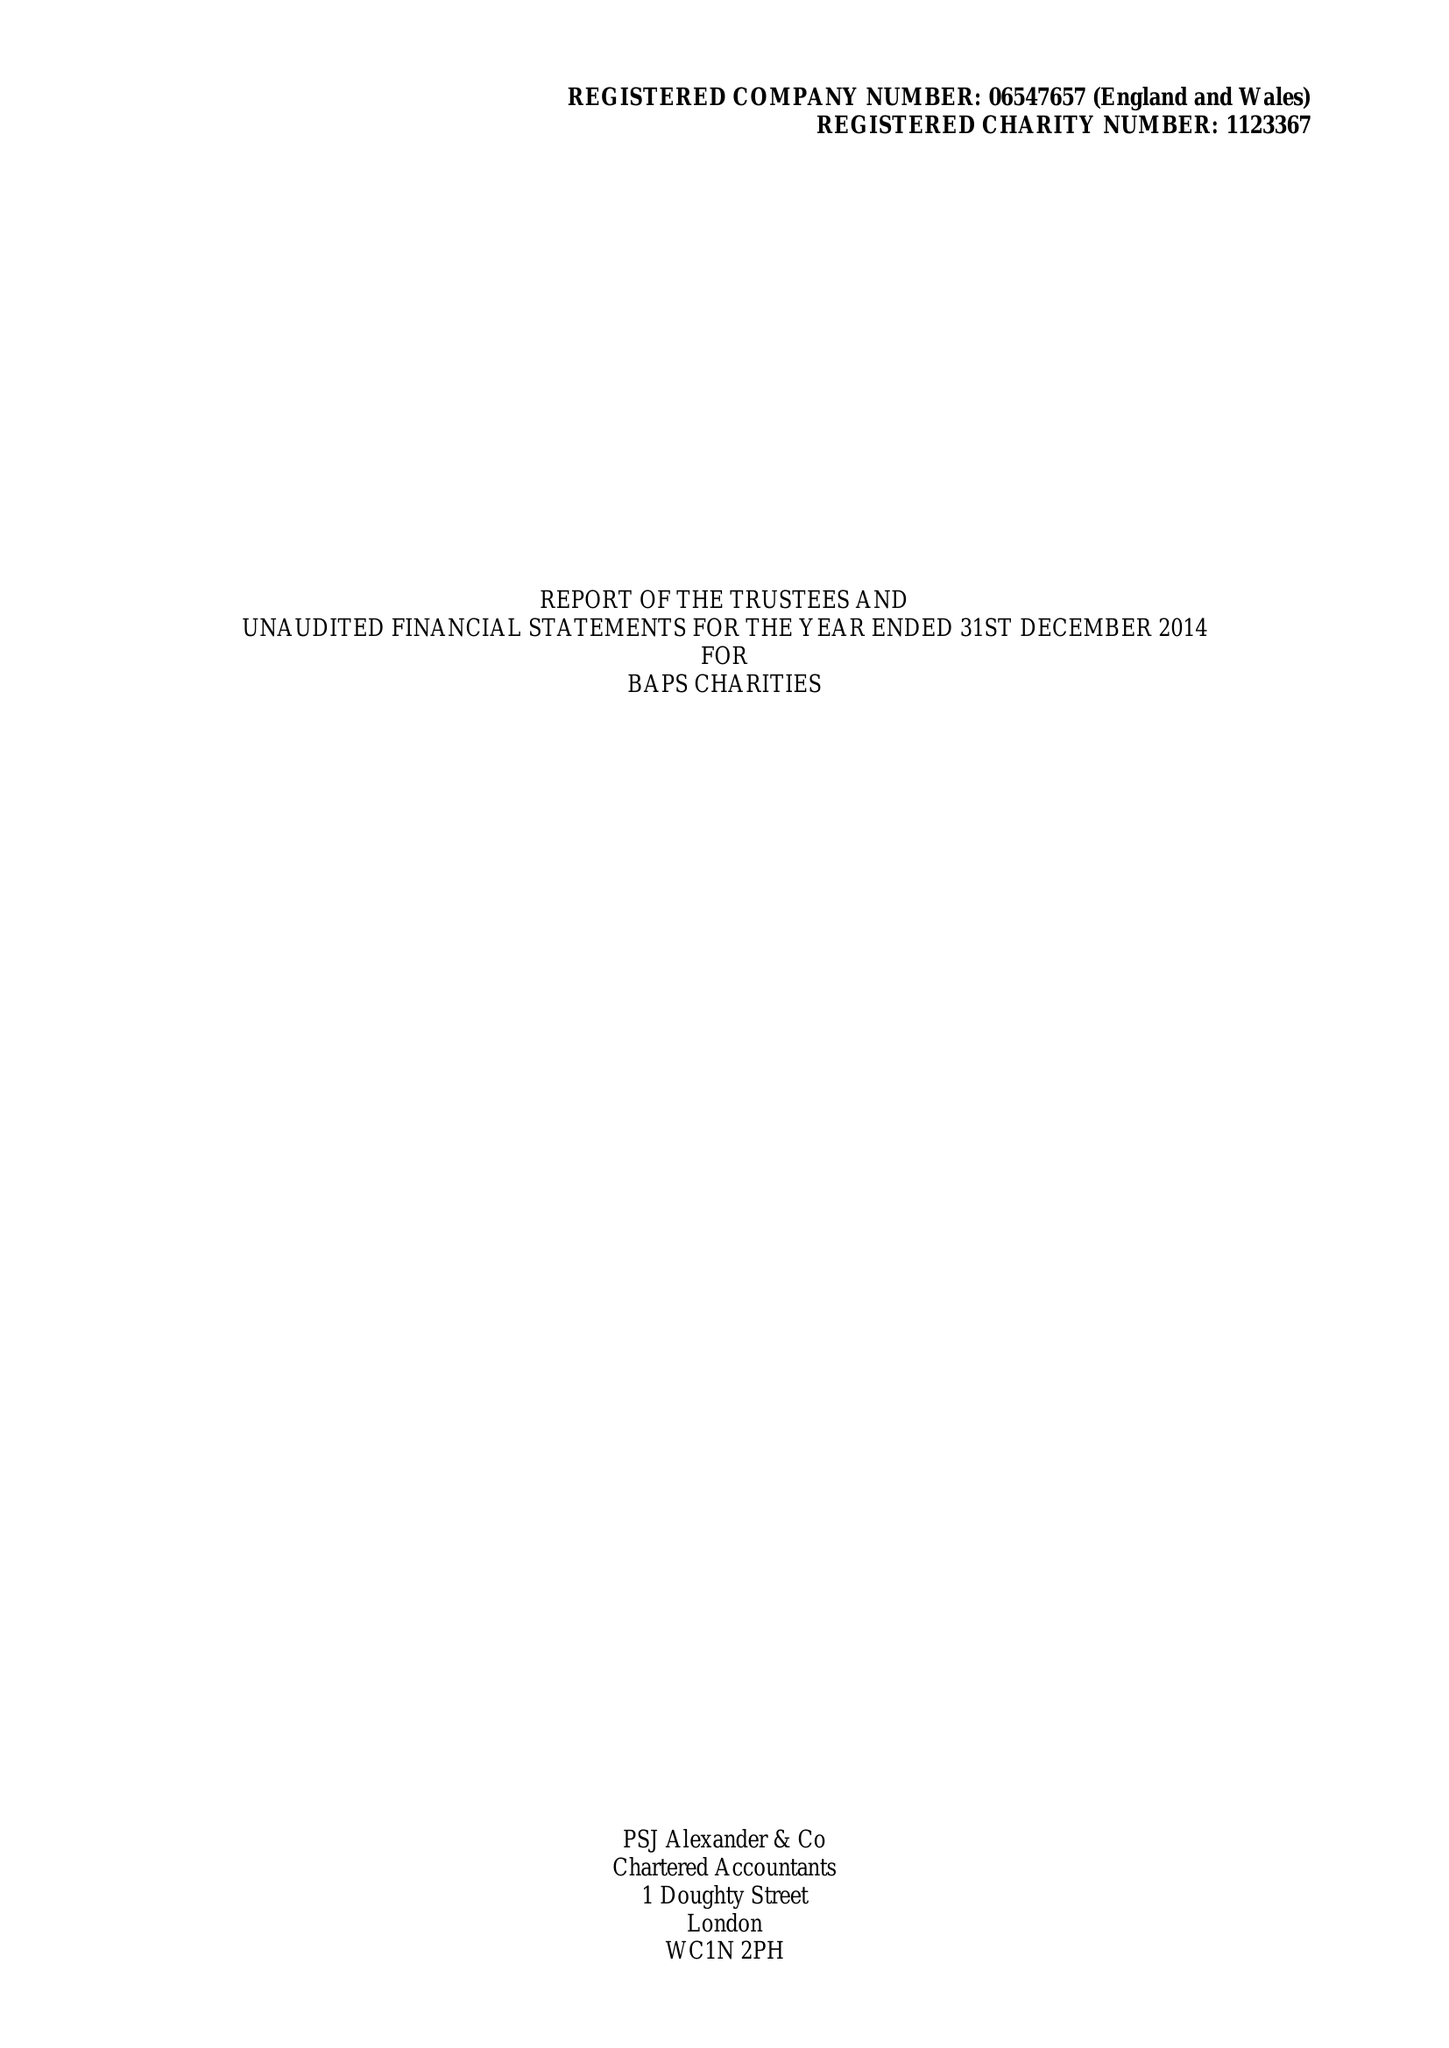What is the value for the spending_annually_in_british_pounds?
Answer the question using a single word or phrase. 77627.00 